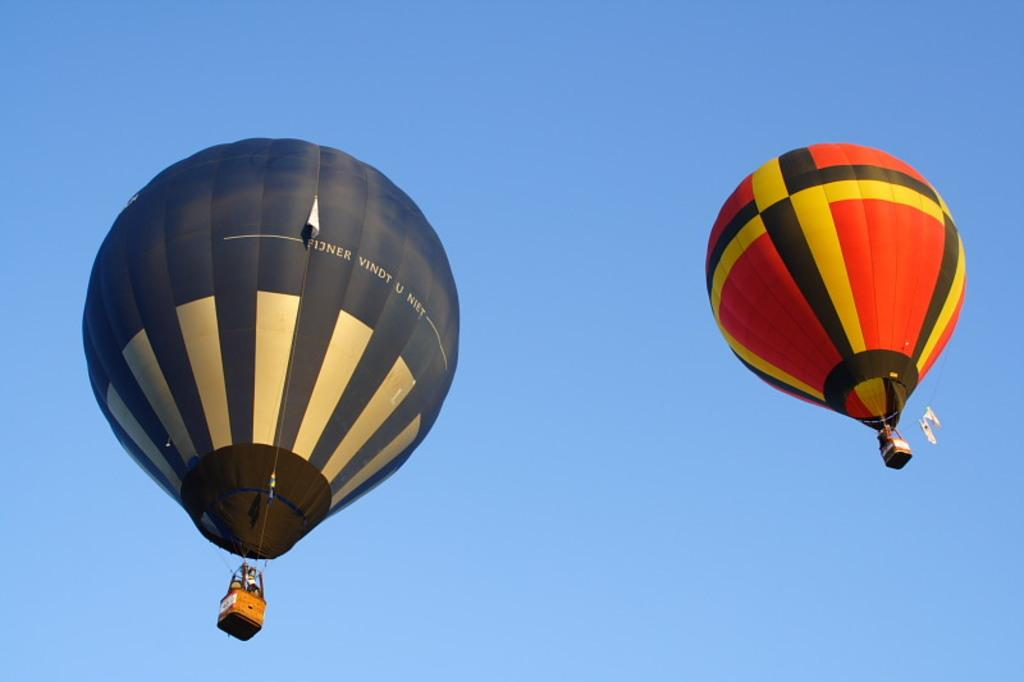What can be seen in the sky in the image? There are two hot air balloons in the image. What are the hot air balloons doing in the image? The hot air balloons are flying in the air. What type of trail can be seen behind the hot air balloons in the image? There is no trail visible behind the hot air balloons in the image. What is the income of the hot air balloon pilots in the image? The income of the hot air balloon pilots cannot be determined from the image. 